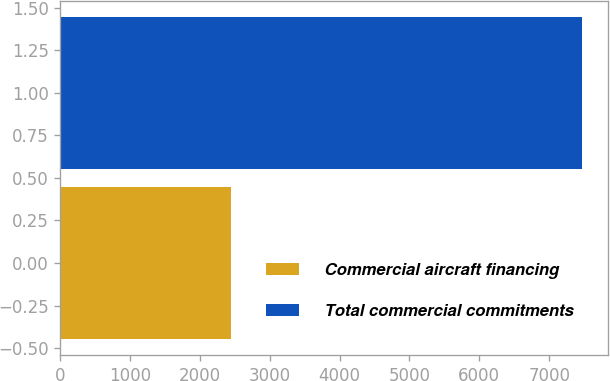Convert chart. <chart><loc_0><loc_0><loc_500><loc_500><bar_chart><fcel>Commercial aircraft financing<fcel>Total commercial commitments<nl><fcel>2445<fcel>7472<nl></chart> 